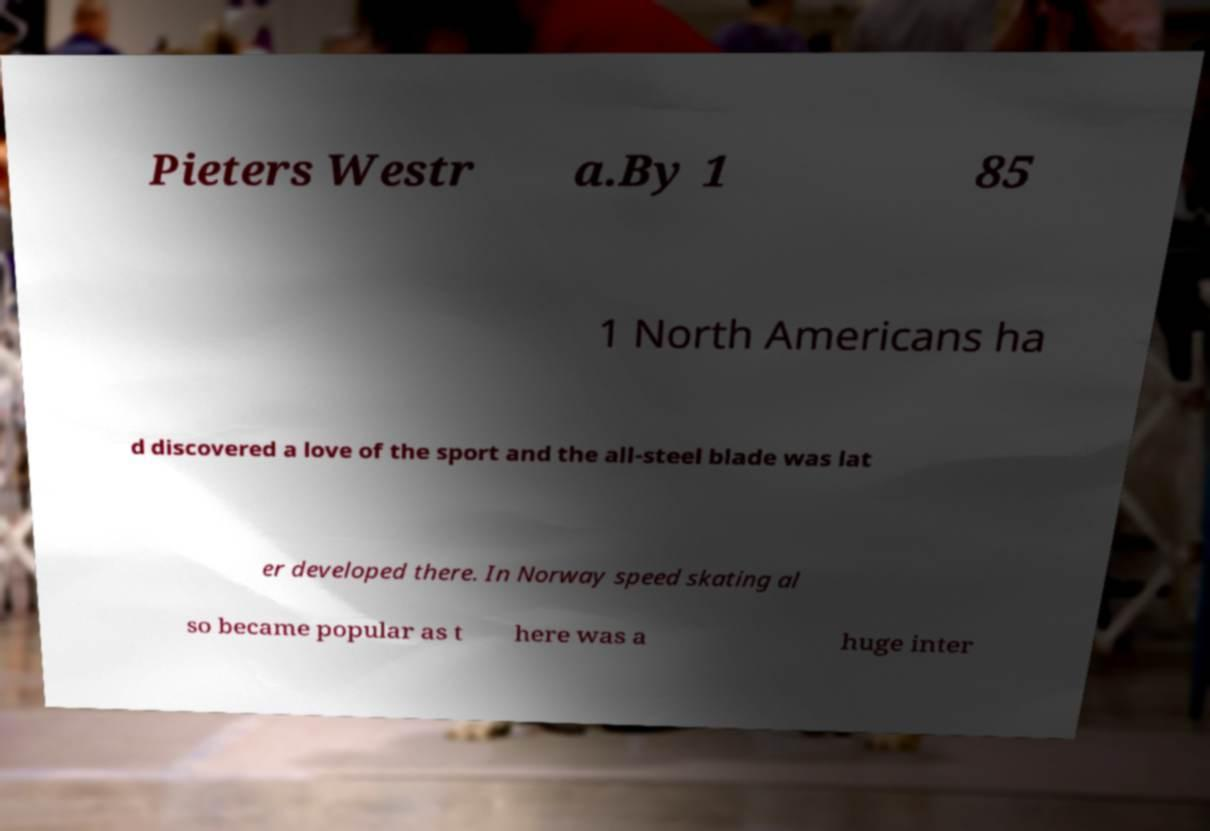Please read and relay the text visible in this image. What does it say? Pieters Westr a.By 1 85 1 North Americans ha d discovered a love of the sport and the all-steel blade was lat er developed there. In Norway speed skating al so became popular as t here was a huge inter 